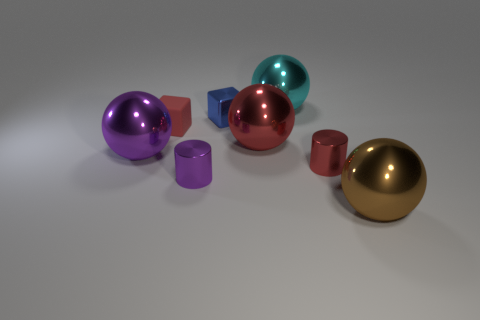Subtract all large cyan shiny blocks. Subtract all cyan metal things. How many objects are left? 7 Add 8 big purple metal spheres. How many big purple metal spheres are left? 9 Add 2 gray balls. How many gray balls exist? 2 Add 1 cyan metallic balls. How many objects exist? 9 Subtract all purple cylinders. How many cylinders are left? 1 Subtract all big cyan balls. How many balls are left? 3 Subtract 1 red blocks. How many objects are left? 7 Subtract all cylinders. How many objects are left? 6 Subtract 2 cylinders. How many cylinders are left? 0 Subtract all red balls. Subtract all yellow cubes. How many balls are left? 3 